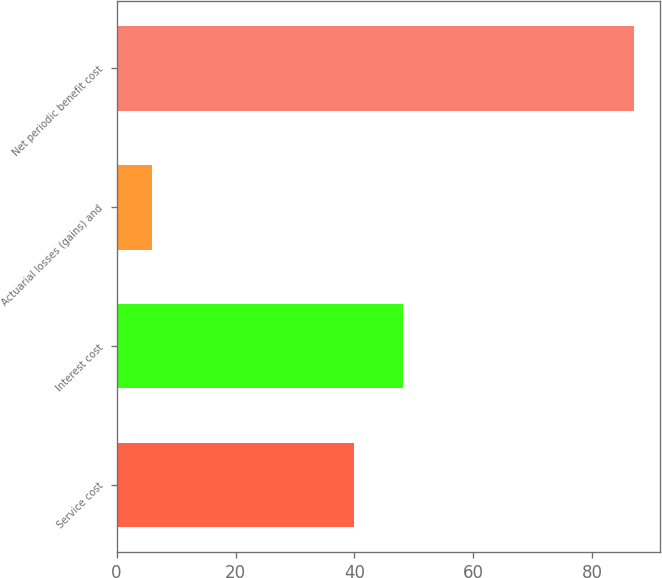Convert chart to OTSL. <chart><loc_0><loc_0><loc_500><loc_500><bar_chart><fcel>Service cost<fcel>Interest cost<fcel>Actuarial losses (gains) and<fcel>Net periodic benefit cost<nl><fcel>40<fcel>48.1<fcel>6<fcel>87<nl></chart> 